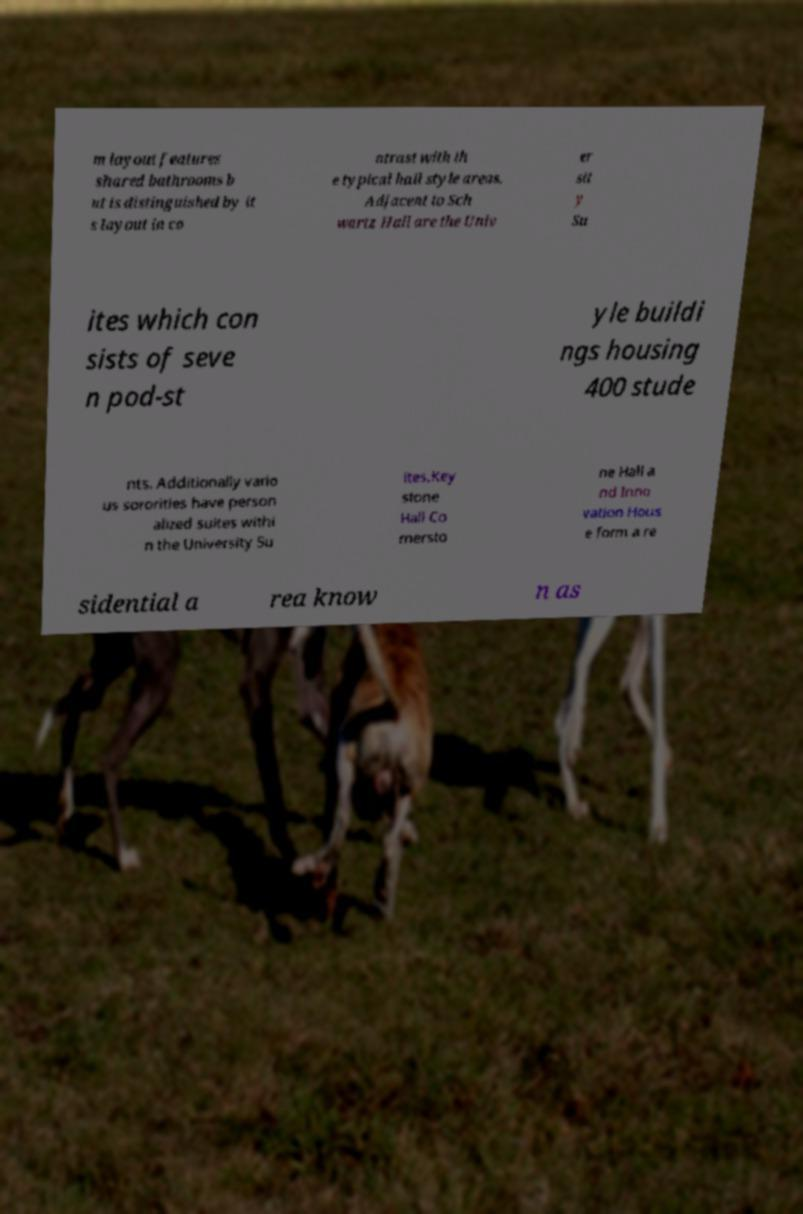I need the written content from this picture converted into text. Can you do that? m layout features shared bathrooms b ut is distinguished by it s layout in co ntrast with th e typical hall style areas. Adjacent to Sch wartz Hall are the Univ er sit y Su ites which con sists of seve n pod-st yle buildi ngs housing 400 stude nts. Additionally vario us sororities have person alized suites withi n the University Su ites.Key stone Hall Co rnersto ne Hall a nd Inno vation Hous e form a re sidential a rea know n as 